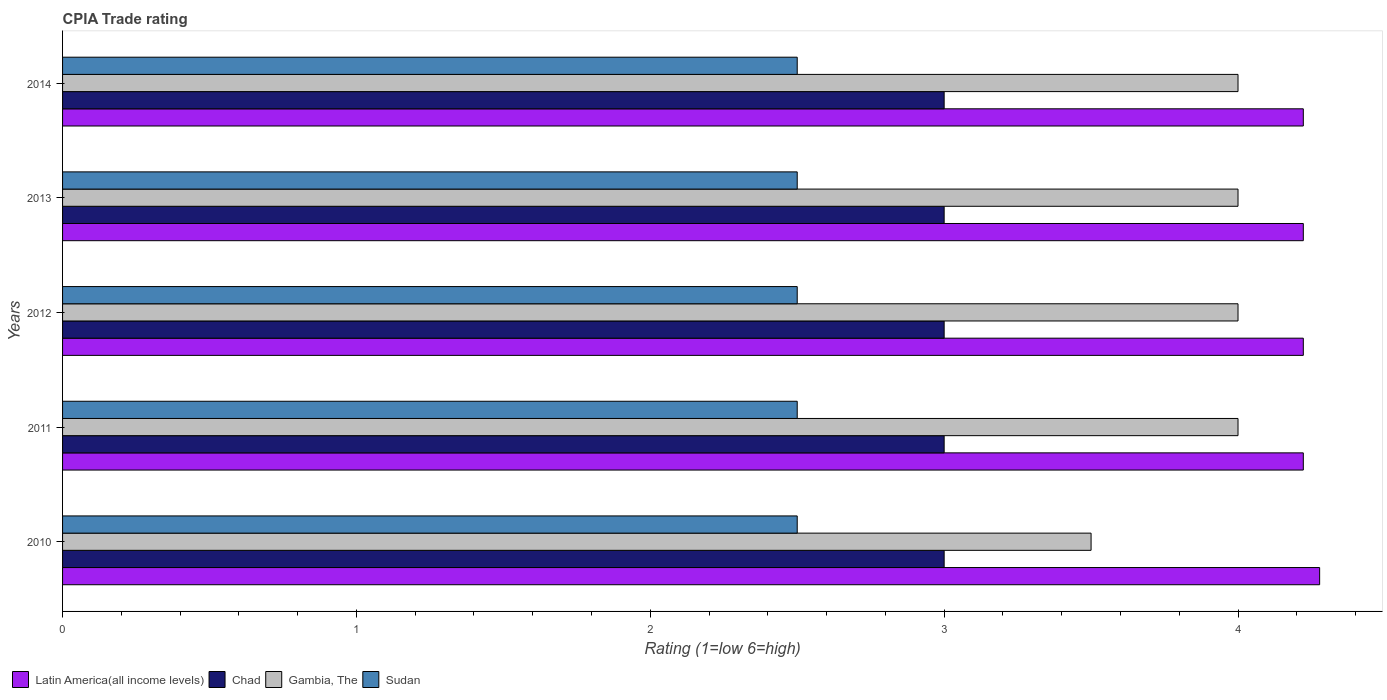How many different coloured bars are there?
Ensure brevity in your answer.  4. How many bars are there on the 1st tick from the bottom?
Offer a very short reply. 4. What is the label of the 4th group of bars from the top?
Make the answer very short. 2011. What is the CPIA rating in Latin America(all income levels) in 2011?
Keep it short and to the point. 4.22. Across all years, what is the maximum CPIA rating in Chad?
Offer a very short reply. 3. Across all years, what is the minimum CPIA rating in Chad?
Your answer should be compact. 3. In which year was the CPIA rating in Chad minimum?
Your response must be concise. 2010. What is the total CPIA rating in Chad in the graph?
Make the answer very short. 15. In the year 2010, what is the difference between the CPIA rating in Chad and CPIA rating in Latin America(all income levels)?
Offer a very short reply. -1.28. In how many years, is the CPIA rating in Sudan greater than 1.2 ?
Give a very brief answer. 5. What is the ratio of the CPIA rating in Chad in 2010 to that in 2013?
Make the answer very short. 1. What is the difference between the highest and the lowest CPIA rating in Gambia, The?
Make the answer very short. 0.5. Is it the case that in every year, the sum of the CPIA rating in Gambia, The and CPIA rating in Latin America(all income levels) is greater than the sum of CPIA rating in Sudan and CPIA rating in Chad?
Offer a very short reply. No. What does the 4th bar from the top in 2011 represents?
Provide a succinct answer. Latin America(all income levels). What does the 3rd bar from the bottom in 2012 represents?
Provide a succinct answer. Gambia, The. How many bars are there?
Make the answer very short. 20. What is the difference between two consecutive major ticks on the X-axis?
Ensure brevity in your answer.  1. Does the graph contain any zero values?
Keep it short and to the point. No. Where does the legend appear in the graph?
Provide a succinct answer. Bottom left. How many legend labels are there?
Your answer should be very brief. 4. How are the legend labels stacked?
Give a very brief answer. Horizontal. What is the title of the graph?
Offer a terse response. CPIA Trade rating. Does "Puerto Rico" appear as one of the legend labels in the graph?
Ensure brevity in your answer.  No. What is the label or title of the X-axis?
Ensure brevity in your answer.  Rating (1=low 6=high). What is the Rating (1=low 6=high) of Latin America(all income levels) in 2010?
Make the answer very short. 4.28. What is the Rating (1=low 6=high) in Chad in 2010?
Ensure brevity in your answer.  3. What is the Rating (1=low 6=high) in Sudan in 2010?
Offer a terse response. 2.5. What is the Rating (1=low 6=high) in Latin America(all income levels) in 2011?
Offer a terse response. 4.22. What is the Rating (1=low 6=high) in Chad in 2011?
Offer a terse response. 3. What is the Rating (1=low 6=high) of Gambia, The in 2011?
Your response must be concise. 4. What is the Rating (1=low 6=high) in Sudan in 2011?
Offer a terse response. 2.5. What is the Rating (1=low 6=high) of Latin America(all income levels) in 2012?
Give a very brief answer. 4.22. What is the Rating (1=low 6=high) in Latin America(all income levels) in 2013?
Your response must be concise. 4.22. What is the Rating (1=low 6=high) of Sudan in 2013?
Offer a terse response. 2.5. What is the Rating (1=low 6=high) in Latin America(all income levels) in 2014?
Provide a short and direct response. 4.22. What is the Rating (1=low 6=high) in Chad in 2014?
Offer a terse response. 3. What is the Rating (1=low 6=high) in Sudan in 2014?
Provide a short and direct response. 2.5. Across all years, what is the maximum Rating (1=low 6=high) in Latin America(all income levels)?
Offer a terse response. 4.28. Across all years, what is the minimum Rating (1=low 6=high) of Latin America(all income levels)?
Provide a succinct answer. 4.22. Across all years, what is the minimum Rating (1=low 6=high) in Chad?
Keep it short and to the point. 3. Across all years, what is the minimum Rating (1=low 6=high) of Sudan?
Offer a terse response. 2.5. What is the total Rating (1=low 6=high) of Latin America(all income levels) in the graph?
Your answer should be compact. 21.17. What is the difference between the Rating (1=low 6=high) in Latin America(all income levels) in 2010 and that in 2011?
Your answer should be compact. 0.06. What is the difference between the Rating (1=low 6=high) in Chad in 2010 and that in 2011?
Ensure brevity in your answer.  0. What is the difference between the Rating (1=low 6=high) of Latin America(all income levels) in 2010 and that in 2012?
Provide a short and direct response. 0.06. What is the difference between the Rating (1=low 6=high) in Chad in 2010 and that in 2012?
Give a very brief answer. 0. What is the difference between the Rating (1=low 6=high) of Sudan in 2010 and that in 2012?
Offer a very short reply. 0. What is the difference between the Rating (1=low 6=high) of Latin America(all income levels) in 2010 and that in 2013?
Ensure brevity in your answer.  0.06. What is the difference between the Rating (1=low 6=high) of Gambia, The in 2010 and that in 2013?
Offer a terse response. -0.5. What is the difference between the Rating (1=low 6=high) in Sudan in 2010 and that in 2013?
Your answer should be compact. 0. What is the difference between the Rating (1=low 6=high) in Latin America(all income levels) in 2010 and that in 2014?
Keep it short and to the point. 0.06. What is the difference between the Rating (1=low 6=high) of Chad in 2010 and that in 2014?
Provide a short and direct response. 0. What is the difference between the Rating (1=low 6=high) of Sudan in 2010 and that in 2014?
Provide a short and direct response. 0. What is the difference between the Rating (1=low 6=high) in Sudan in 2011 and that in 2012?
Your answer should be very brief. 0. What is the difference between the Rating (1=low 6=high) of Chad in 2011 and that in 2013?
Provide a short and direct response. 0. What is the difference between the Rating (1=low 6=high) in Sudan in 2011 and that in 2013?
Your answer should be very brief. 0. What is the difference between the Rating (1=low 6=high) of Latin America(all income levels) in 2011 and that in 2014?
Offer a terse response. 0. What is the difference between the Rating (1=low 6=high) in Gambia, The in 2011 and that in 2014?
Provide a succinct answer. 0. What is the difference between the Rating (1=low 6=high) of Sudan in 2011 and that in 2014?
Keep it short and to the point. 0. What is the difference between the Rating (1=low 6=high) of Latin America(all income levels) in 2012 and that in 2013?
Offer a very short reply. 0. What is the difference between the Rating (1=low 6=high) in Chad in 2012 and that in 2013?
Provide a short and direct response. 0. What is the difference between the Rating (1=low 6=high) in Gambia, The in 2012 and that in 2013?
Keep it short and to the point. 0. What is the difference between the Rating (1=low 6=high) of Latin America(all income levels) in 2012 and that in 2014?
Give a very brief answer. 0. What is the difference between the Rating (1=low 6=high) of Chad in 2013 and that in 2014?
Offer a very short reply. 0. What is the difference between the Rating (1=low 6=high) in Gambia, The in 2013 and that in 2014?
Offer a terse response. 0. What is the difference between the Rating (1=low 6=high) of Latin America(all income levels) in 2010 and the Rating (1=low 6=high) of Chad in 2011?
Make the answer very short. 1.28. What is the difference between the Rating (1=low 6=high) in Latin America(all income levels) in 2010 and the Rating (1=low 6=high) in Gambia, The in 2011?
Keep it short and to the point. 0.28. What is the difference between the Rating (1=low 6=high) of Latin America(all income levels) in 2010 and the Rating (1=low 6=high) of Sudan in 2011?
Keep it short and to the point. 1.78. What is the difference between the Rating (1=low 6=high) in Chad in 2010 and the Rating (1=low 6=high) in Gambia, The in 2011?
Keep it short and to the point. -1. What is the difference between the Rating (1=low 6=high) of Latin America(all income levels) in 2010 and the Rating (1=low 6=high) of Chad in 2012?
Your answer should be very brief. 1.28. What is the difference between the Rating (1=low 6=high) in Latin America(all income levels) in 2010 and the Rating (1=low 6=high) in Gambia, The in 2012?
Keep it short and to the point. 0.28. What is the difference between the Rating (1=low 6=high) in Latin America(all income levels) in 2010 and the Rating (1=low 6=high) in Sudan in 2012?
Your response must be concise. 1.78. What is the difference between the Rating (1=low 6=high) of Chad in 2010 and the Rating (1=low 6=high) of Gambia, The in 2012?
Provide a succinct answer. -1. What is the difference between the Rating (1=low 6=high) of Chad in 2010 and the Rating (1=low 6=high) of Sudan in 2012?
Your answer should be compact. 0.5. What is the difference between the Rating (1=low 6=high) of Latin America(all income levels) in 2010 and the Rating (1=low 6=high) of Chad in 2013?
Give a very brief answer. 1.28. What is the difference between the Rating (1=low 6=high) in Latin America(all income levels) in 2010 and the Rating (1=low 6=high) in Gambia, The in 2013?
Make the answer very short. 0.28. What is the difference between the Rating (1=low 6=high) in Latin America(all income levels) in 2010 and the Rating (1=low 6=high) in Sudan in 2013?
Offer a terse response. 1.78. What is the difference between the Rating (1=low 6=high) of Chad in 2010 and the Rating (1=low 6=high) of Gambia, The in 2013?
Offer a very short reply. -1. What is the difference between the Rating (1=low 6=high) in Chad in 2010 and the Rating (1=low 6=high) in Sudan in 2013?
Your response must be concise. 0.5. What is the difference between the Rating (1=low 6=high) of Gambia, The in 2010 and the Rating (1=low 6=high) of Sudan in 2013?
Provide a short and direct response. 1. What is the difference between the Rating (1=low 6=high) of Latin America(all income levels) in 2010 and the Rating (1=low 6=high) of Chad in 2014?
Provide a short and direct response. 1.28. What is the difference between the Rating (1=low 6=high) in Latin America(all income levels) in 2010 and the Rating (1=low 6=high) in Gambia, The in 2014?
Your answer should be very brief. 0.28. What is the difference between the Rating (1=low 6=high) in Latin America(all income levels) in 2010 and the Rating (1=low 6=high) in Sudan in 2014?
Ensure brevity in your answer.  1.78. What is the difference between the Rating (1=low 6=high) in Chad in 2010 and the Rating (1=low 6=high) in Sudan in 2014?
Your answer should be very brief. 0.5. What is the difference between the Rating (1=low 6=high) in Latin America(all income levels) in 2011 and the Rating (1=low 6=high) in Chad in 2012?
Make the answer very short. 1.22. What is the difference between the Rating (1=low 6=high) of Latin America(all income levels) in 2011 and the Rating (1=low 6=high) of Gambia, The in 2012?
Your answer should be compact. 0.22. What is the difference between the Rating (1=low 6=high) in Latin America(all income levels) in 2011 and the Rating (1=low 6=high) in Sudan in 2012?
Keep it short and to the point. 1.72. What is the difference between the Rating (1=low 6=high) in Chad in 2011 and the Rating (1=low 6=high) in Gambia, The in 2012?
Your response must be concise. -1. What is the difference between the Rating (1=low 6=high) of Chad in 2011 and the Rating (1=low 6=high) of Sudan in 2012?
Offer a terse response. 0.5. What is the difference between the Rating (1=low 6=high) of Gambia, The in 2011 and the Rating (1=low 6=high) of Sudan in 2012?
Keep it short and to the point. 1.5. What is the difference between the Rating (1=low 6=high) in Latin America(all income levels) in 2011 and the Rating (1=low 6=high) in Chad in 2013?
Offer a very short reply. 1.22. What is the difference between the Rating (1=low 6=high) in Latin America(all income levels) in 2011 and the Rating (1=low 6=high) in Gambia, The in 2013?
Your response must be concise. 0.22. What is the difference between the Rating (1=low 6=high) in Latin America(all income levels) in 2011 and the Rating (1=low 6=high) in Sudan in 2013?
Your response must be concise. 1.72. What is the difference between the Rating (1=low 6=high) in Chad in 2011 and the Rating (1=low 6=high) in Sudan in 2013?
Your answer should be very brief. 0.5. What is the difference between the Rating (1=low 6=high) in Latin America(all income levels) in 2011 and the Rating (1=low 6=high) in Chad in 2014?
Provide a succinct answer. 1.22. What is the difference between the Rating (1=low 6=high) of Latin America(all income levels) in 2011 and the Rating (1=low 6=high) of Gambia, The in 2014?
Your answer should be compact. 0.22. What is the difference between the Rating (1=low 6=high) in Latin America(all income levels) in 2011 and the Rating (1=low 6=high) in Sudan in 2014?
Your response must be concise. 1.72. What is the difference between the Rating (1=low 6=high) of Chad in 2011 and the Rating (1=low 6=high) of Gambia, The in 2014?
Offer a very short reply. -1. What is the difference between the Rating (1=low 6=high) in Chad in 2011 and the Rating (1=low 6=high) in Sudan in 2014?
Give a very brief answer. 0.5. What is the difference between the Rating (1=low 6=high) in Latin America(all income levels) in 2012 and the Rating (1=low 6=high) in Chad in 2013?
Offer a terse response. 1.22. What is the difference between the Rating (1=low 6=high) of Latin America(all income levels) in 2012 and the Rating (1=low 6=high) of Gambia, The in 2013?
Your answer should be very brief. 0.22. What is the difference between the Rating (1=low 6=high) of Latin America(all income levels) in 2012 and the Rating (1=low 6=high) of Sudan in 2013?
Your answer should be compact. 1.72. What is the difference between the Rating (1=low 6=high) in Chad in 2012 and the Rating (1=low 6=high) in Sudan in 2013?
Give a very brief answer. 0.5. What is the difference between the Rating (1=low 6=high) of Latin America(all income levels) in 2012 and the Rating (1=low 6=high) of Chad in 2014?
Your answer should be compact. 1.22. What is the difference between the Rating (1=low 6=high) of Latin America(all income levels) in 2012 and the Rating (1=low 6=high) of Gambia, The in 2014?
Your answer should be very brief. 0.22. What is the difference between the Rating (1=low 6=high) in Latin America(all income levels) in 2012 and the Rating (1=low 6=high) in Sudan in 2014?
Your response must be concise. 1.72. What is the difference between the Rating (1=low 6=high) of Chad in 2012 and the Rating (1=low 6=high) of Gambia, The in 2014?
Your answer should be very brief. -1. What is the difference between the Rating (1=low 6=high) of Chad in 2012 and the Rating (1=low 6=high) of Sudan in 2014?
Ensure brevity in your answer.  0.5. What is the difference between the Rating (1=low 6=high) in Latin America(all income levels) in 2013 and the Rating (1=low 6=high) in Chad in 2014?
Keep it short and to the point. 1.22. What is the difference between the Rating (1=low 6=high) of Latin America(all income levels) in 2013 and the Rating (1=low 6=high) of Gambia, The in 2014?
Give a very brief answer. 0.22. What is the difference between the Rating (1=low 6=high) of Latin America(all income levels) in 2013 and the Rating (1=low 6=high) of Sudan in 2014?
Your answer should be compact. 1.72. What is the difference between the Rating (1=low 6=high) in Chad in 2013 and the Rating (1=low 6=high) in Sudan in 2014?
Your answer should be very brief. 0.5. What is the average Rating (1=low 6=high) in Latin America(all income levels) per year?
Keep it short and to the point. 4.23. What is the average Rating (1=low 6=high) of Sudan per year?
Make the answer very short. 2.5. In the year 2010, what is the difference between the Rating (1=low 6=high) in Latin America(all income levels) and Rating (1=low 6=high) in Chad?
Your answer should be compact. 1.28. In the year 2010, what is the difference between the Rating (1=low 6=high) of Latin America(all income levels) and Rating (1=low 6=high) of Gambia, The?
Keep it short and to the point. 0.78. In the year 2010, what is the difference between the Rating (1=low 6=high) in Latin America(all income levels) and Rating (1=low 6=high) in Sudan?
Provide a short and direct response. 1.78. In the year 2010, what is the difference between the Rating (1=low 6=high) of Chad and Rating (1=low 6=high) of Sudan?
Keep it short and to the point. 0.5. In the year 2010, what is the difference between the Rating (1=low 6=high) of Gambia, The and Rating (1=low 6=high) of Sudan?
Keep it short and to the point. 1. In the year 2011, what is the difference between the Rating (1=low 6=high) in Latin America(all income levels) and Rating (1=low 6=high) in Chad?
Ensure brevity in your answer.  1.22. In the year 2011, what is the difference between the Rating (1=low 6=high) of Latin America(all income levels) and Rating (1=low 6=high) of Gambia, The?
Ensure brevity in your answer.  0.22. In the year 2011, what is the difference between the Rating (1=low 6=high) of Latin America(all income levels) and Rating (1=low 6=high) of Sudan?
Make the answer very short. 1.72. In the year 2011, what is the difference between the Rating (1=low 6=high) in Chad and Rating (1=low 6=high) in Gambia, The?
Your answer should be very brief. -1. In the year 2011, what is the difference between the Rating (1=low 6=high) in Chad and Rating (1=low 6=high) in Sudan?
Your answer should be compact. 0.5. In the year 2012, what is the difference between the Rating (1=low 6=high) in Latin America(all income levels) and Rating (1=low 6=high) in Chad?
Offer a terse response. 1.22. In the year 2012, what is the difference between the Rating (1=low 6=high) of Latin America(all income levels) and Rating (1=low 6=high) of Gambia, The?
Offer a very short reply. 0.22. In the year 2012, what is the difference between the Rating (1=low 6=high) of Latin America(all income levels) and Rating (1=low 6=high) of Sudan?
Ensure brevity in your answer.  1.72. In the year 2012, what is the difference between the Rating (1=low 6=high) in Chad and Rating (1=low 6=high) in Gambia, The?
Keep it short and to the point. -1. In the year 2012, what is the difference between the Rating (1=low 6=high) in Chad and Rating (1=low 6=high) in Sudan?
Offer a terse response. 0.5. In the year 2013, what is the difference between the Rating (1=low 6=high) of Latin America(all income levels) and Rating (1=low 6=high) of Chad?
Your answer should be compact. 1.22. In the year 2013, what is the difference between the Rating (1=low 6=high) of Latin America(all income levels) and Rating (1=low 6=high) of Gambia, The?
Give a very brief answer. 0.22. In the year 2013, what is the difference between the Rating (1=low 6=high) of Latin America(all income levels) and Rating (1=low 6=high) of Sudan?
Provide a short and direct response. 1.72. In the year 2013, what is the difference between the Rating (1=low 6=high) of Chad and Rating (1=low 6=high) of Gambia, The?
Your answer should be very brief. -1. In the year 2013, what is the difference between the Rating (1=low 6=high) in Chad and Rating (1=low 6=high) in Sudan?
Your response must be concise. 0.5. In the year 2013, what is the difference between the Rating (1=low 6=high) of Gambia, The and Rating (1=low 6=high) of Sudan?
Your response must be concise. 1.5. In the year 2014, what is the difference between the Rating (1=low 6=high) of Latin America(all income levels) and Rating (1=low 6=high) of Chad?
Provide a short and direct response. 1.22. In the year 2014, what is the difference between the Rating (1=low 6=high) in Latin America(all income levels) and Rating (1=low 6=high) in Gambia, The?
Your answer should be very brief. 0.22. In the year 2014, what is the difference between the Rating (1=low 6=high) in Latin America(all income levels) and Rating (1=low 6=high) in Sudan?
Provide a short and direct response. 1.72. In the year 2014, what is the difference between the Rating (1=low 6=high) in Chad and Rating (1=low 6=high) in Gambia, The?
Your answer should be very brief. -1. In the year 2014, what is the difference between the Rating (1=low 6=high) in Gambia, The and Rating (1=low 6=high) in Sudan?
Make the answer very short. 1.5. What is the ratio of the Rating (1=low 6=high) in Latin America(all income levels) in 2010 to that in 2011?
Ensure brevity in your answer.  1.01. What is the ratio of the Rating (1=low 6=high) of Chad in 2010 to that in 2011?
Keep it short and to the point. 1. What is the ratio of the Rating (1=low 6=high) of Gambia, The in 2010 to that in 2011?
Provide a short and direct response. 0.88. What is the ratio of the Rating (1=low 6=high) of Latin America(all income levels) in 2010 to that in 2012?
Your response must be concise. 1.01. What is the ratio of the Rating (1=low 6=high) in Sudan in 2010 to that in 2012?
Give a very brief answer. 1. What is the ratio of the Rating (1=low 6=high) of Latin America(all income levels) in 2010 to that in 2013?
Ensure brevity in your answer.  1.01. What is the ratio of the Rating (1=low 6=high) of Chad in 2010 to that in 2013?
Offer a very short reply. 1. What is the ratio of the Rating (1=low 6=high) in Gambia, The in 2010 to that in 2013?
Offer a terse response. 0.88. What is the ratio of the Rating (1=low 6=high) of Sudan in 2010 to that in 2013?
Your response must be concise. 1. What is the ratio of the Rating (1=low 6=high) of Latin America(all income levels) in 2010 to that in 2014?
Keep it short and to the point. 1.01. What is the ratio of the Rating (1=low 6=high) in Chad in 2010 to that in 2014?
Your answer should be very brief. 1. What is the ratio of the Rating (1=low 6=high) in Sudan in 2010 to that in 2014?
Your response must be concise. 1. What is the ratio of the Rating (1=low 6=high) in Chad in 2011 to that in 2012?
Provide a short and direct response. 1. What is the ratio of the Rating (1=low 6=high) in Sudan in 2011 to that in 2012?
Provide a succinct answer. 1. What is the ratio of the Rating (1=low 6=high) in Latin America(all income levels) in 2011 to that in 2013?
Provide a short and direct response. 1. What is the ratio of the Rating (1=low 6=high) in Sudan in 2011 to that in 2013?
Offer a very short reply. 1. What is the ratio of the Rating (1=low 6=high) in Chad in 2011 to that in 2014?
Ensure brevity in your answer.  1. What is the ratio of the Rating (1=low 6=high) in Gambia, The in 2011 to that in 2014?
Your answer should be compact. 1. What is the ratio of the Rating (1=low 6=high) in Latin America(all income levels) in 2012 to that in 2014?
Your answer should be compact. 1. What is the ratio of the Rating (1=low 6=high) in Chad in 2012 to that in 2014?
Offer a terse response. 1. What is the ratio of the Rating (1=low 6=high) of Sudan in 2012 to that in 2014?
Your answer should be compact. 1. What is the ratio of the Rating (1=low 6=high) in Sudan in 2013 to that in 2014?
Offer a terse response. 1. What is the difference between the highest and the second highest Rating (1=low 6=high) in Latin America(all income levels)?
Provide a short and direct response. 0.06. What is the difference between the highest and the lowest Rating (1=low 6=high) of Latin America(all income levels)?
Your answer should be very brief. 0.06. What is the difference between the highest and the lowest Rating (1=low 6=high) of Chad?
Offer a terse response. 0. What is the difference between the highest and the lowest Rating (1=low 6=high) of Sudan?
Ensure brevity in your answer.  0. 